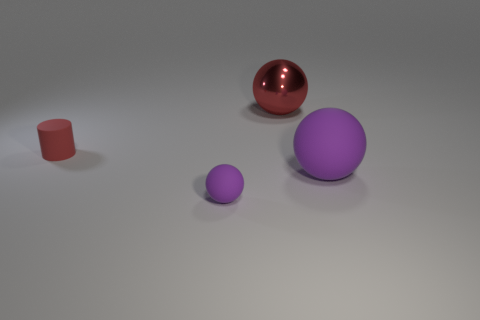Subtract all big balls. How many balls are left? 1 Subtract all red balls. How many balls are left? 2 Add 1 small red matte things. How many objects exist? 5 Subtract all cylinders. How many objects are left? 3 Subtract 1 balls. How many balls are left? 2 Subtract all green spheres. Subtract all red cubes. How many spheres are left? 3 Subtract all purple cylinders. How many purple spheres are left? 2 Subtract all tiny brown matte balls. Subtract all spheres. How many objects are left? 1 Add 2 large purple matte objects. How many large purple matte objects are left? 3 Add 3 large green shiny blocks. How many large green shiny blocks exist? 3 